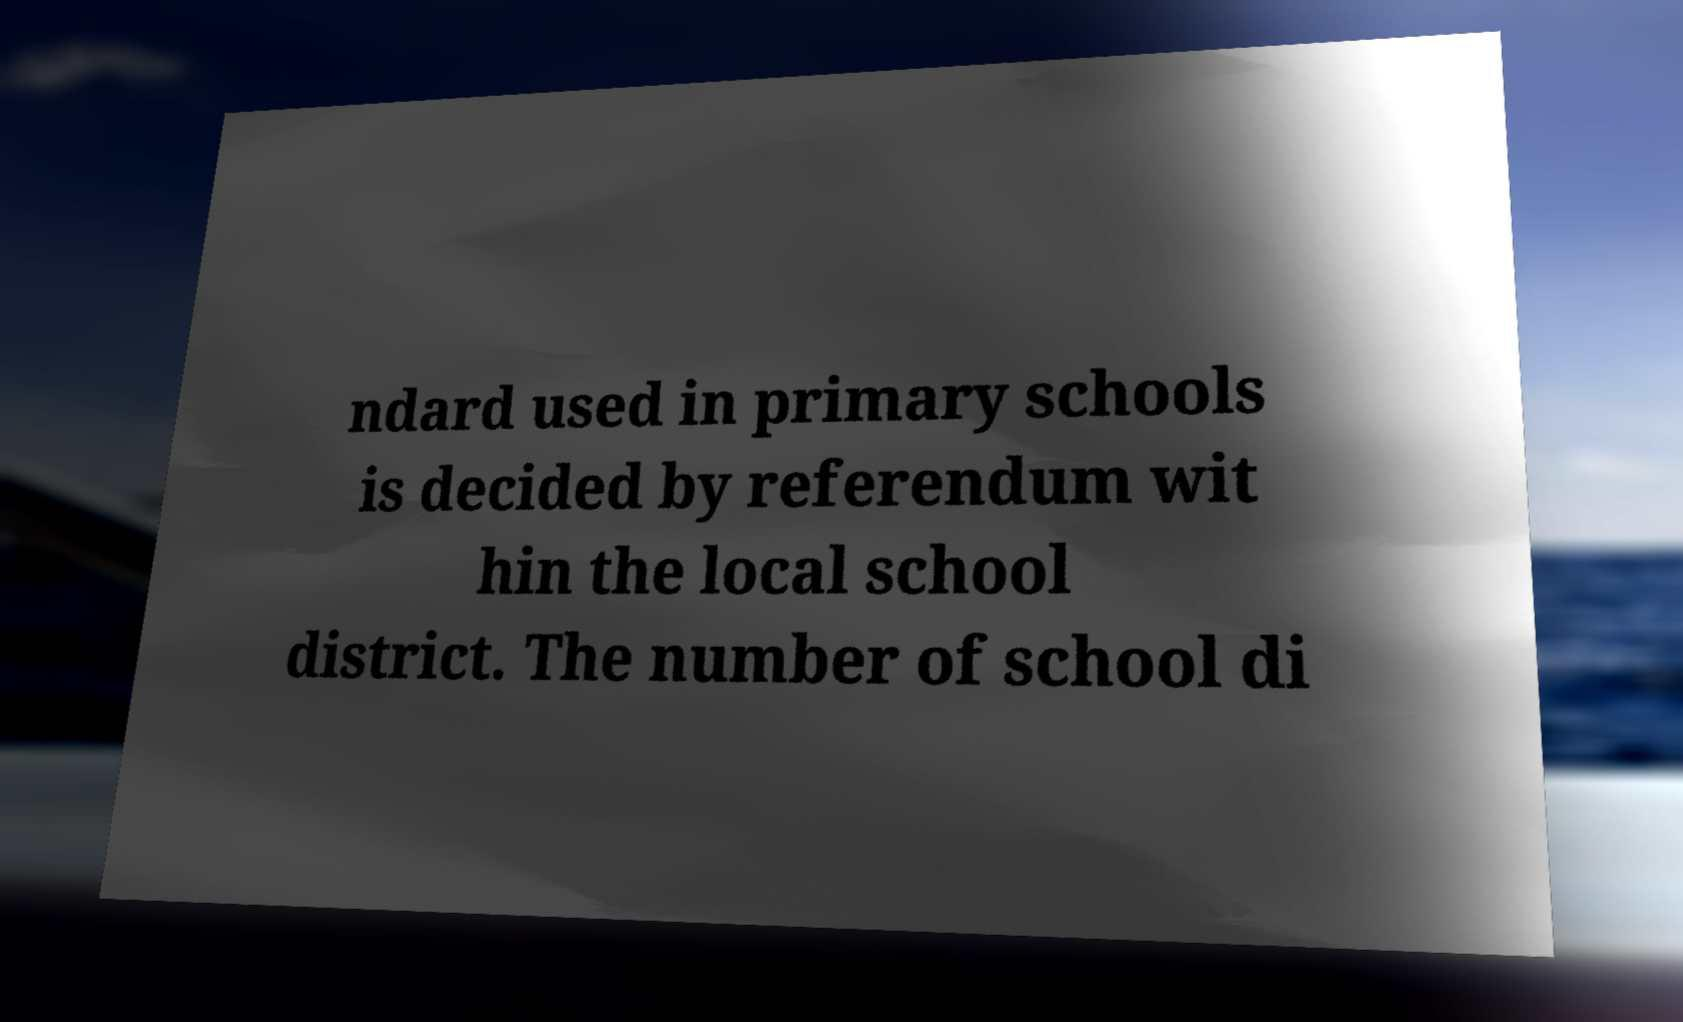Can you accurately transcribe the text from the provided image for me? ndard used in primary schools is decided by referendum wit hin the local school district. The number of school di 